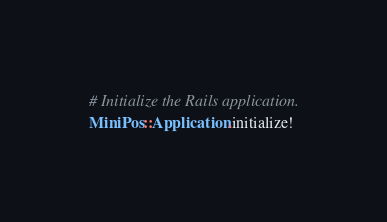<code> <loc_0><loc_0><loc_500><loc_500><_Ruby_>
# Initialize the Rails application.
MiniPos::Application.initialize!
</code> 